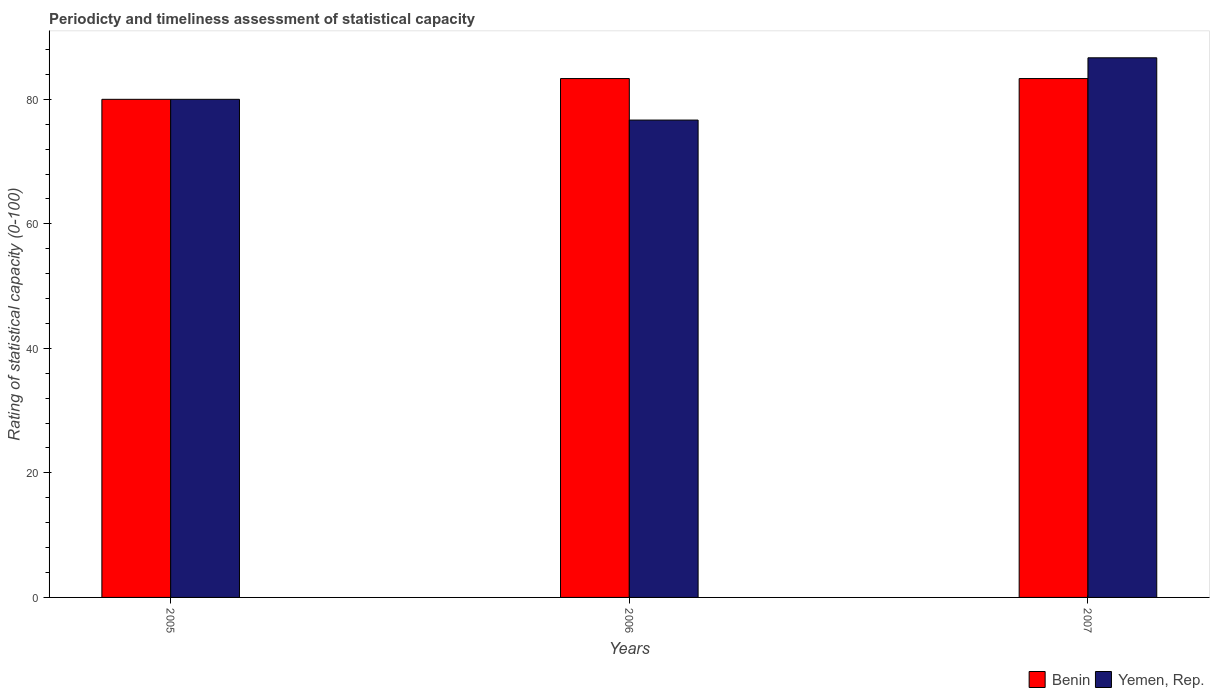How many different coloured bars are there?
Ensure brevity in your answer.  2. Are the number of bars per tick equal to the number of legend labels?
Your response must be concise. Yes. Are the number of bars on each tick of the X-axis equal?
Keep it short and to the point. Yes. How many bars are there on the 1st tick from the right?
Keep it short and to the point. 2. In how many cases, is the number of bars for a given year not equal to the number of legend labels?
Offer a terse response. 0. What is the rating of statistical capacity in Benin in 2007?
Make the answer very short. 83.33. Across all years, what is the maximum rating of statistical capacity in Yemen, Rep.?
Provide a short and direct response. 86.67. Across all years, what is the minimum rating of statistical capacity in Yemen, Rep.?
Make the answer very short. 76.67. In which year was the rating of statistical capacity in Benin maximum?
Keep it short and to the point. 2006. What is the total rating of statistical capacity in Benin in the graph?
Make the answer very short. 246.67. What is the difference between the rating of statistical capacity in Benin in 2006 and that in 2007?
Provide a succinct answer. 0. What is the difference between the rating of statistical capacity in Benin in 2007 and the rating of statistical capacity in Yemen, Rep. in 2005?
Your response must be concise. 3.33. What is the average rating of statistical capacity in Yemen, Rep. per year?
Offer a very short reply. 81.11. In the year 2005, what is the difference between the rating of statistical capacity in Yemen, Rep. and rating of statistical capacity in Benin?
Your answer should be compact. 0. What is the ratio of the rating of statistical capacity in Yemen, Rep. in 2005 to that in 2006?
Give a very brief answer. 1.04. Is the difference between the rating of statistical capacity in Yemen, Rep. in 2005 and 2007 greater than the difference between the rating of statistical capacity in Benin in 2005 and 2007?
Your answer should be very brief. No. In how many years, is the rating of statistical capacity in Benin greater than the average rating of statistical capacity in Benin taken over all years?
Your response must be concise. 2. What does the 1st bar from the left in 2005 represents?
Offer a terse response. Benin. What does the 1st bar from the right in 2005 represents?
Your answer should be very brief. Yemen, Rep. Are all the bars in the graph horizontal?
Keep it short and to the point. No. Does the graph contain grids?
Provide a short and direct response. No. Where does the legend appear in the graph?
Offer a very short reply. Bottom right. How are the legend labels stacked?
Your answer should be compact. Horizontal. What is the title of the graph?
Keep it short and to the point. Periodicty and timeliness assessment of statistical capacity. What is the label or title of the X-axis?
Provide a succinct answer. Years. What is the label or title of the Y-axis?
Make the answer very short. Rating of statistical capacity (0-100). What is the Rating of statistical capacity (0-100) in Benin in 2005?
Offer a terse response. 80. What is the Rating of statistical capacity (0-100) in Yemen, Rep. in 2005?
Provide a short and direct response. 80. What is the Rating of statistical capacity (0-100) in Benin in 2006?
Offer a terse response. 83.33. What is the Rating of statistical capacity (0-100) of Yemen, Rep. in 2006?
Provide a short and direct response. 76.67. What is the Rating of statistical capacity (0-100) of Benin in 2007?
Give a very brief answer. 83.33. What is the Rating of statistical capacity (0-100) of Yemen, Rep. in 2007?
Provide a short and direct response. 86.67. Across all years, what is the maximum Rating of statistical capacity (0-100) of Benin?
Your answer should be compact. 83.33. Across all years, what is the maximum Rating of statistical capacity (0-100) in Yemen, Rep.?
Offer a terse response. 86.67. Across all years, what is the minimum Rating of statistical capacity (0-100) in Yemen, Rep.?
Provide a short and direct response. 76.67. What is the total Rating of statistical capacity (0-100) in Benin in the graph?
Provide a succinct answer. 246.67. What is the total Rating of statistical capacity (0-100) of Yemen, Rep. in the graph?
Keep it short and to the point. 243.33. What is the difference between the Rating of statistical capacity (0-100) in Benin in 2005 and that in 2006?
Provide a succinct answer. -3.33. What is the difference between the Rating of statistical capacity (0-100) of Yemen, Rep. in 2005 and that in 2006?
Your answer should be very brief. 3.33. What is the difference between the Rating of statistical capacity (0-100) of Benin in 2005 and that in 2007?
Offer a terse response. -3.33. What is the difference between the Rating of statistical capacity (0-100) of Yemen, Rep. in 2005 and that in 2007?
Your answer should be compact. -6.67. What is the difference between the Rating of statistical capacity (0-100) of Yemen, Rep. in 2006 and that in 2007?
Offer a very short reply. -10. What is the difference between the Rating of statistical capacity (0-100) of Benin in 2005 and the Rating of statistical capacity (0-100) of Yemen, Rep. in 2006?
Ensure brevity in your answer.  3.33. What is the difference between the Rating of statistical capacity (0-100) of Benin in 2005 and the Rating of statistical capacity (0-100) of Yemen, Rep. in 2007?
Provide a succinct answer. -6.67. What is the difference between the Rating of statistical capacity (0-100) of Benin in 2006 and the Rating of statistical capacity (0-100) of Yemen, Rep. in 2007?
Provide a succinct answer. -3.33. What is the average Rating of statistical capacity (0-100) of Benin per year?
Provide a short and direct response. 82.22. What is the average Rating of statistical capacity (0-100) of Yemen, Rep. per year?
Provide a short and direct response. 81.11. In the year 2006, what is the difference between the Rating of statistical capacity (0-100) in Benin and Rating of statistical capacity (0-100) in Yemen, Rep.?
Provide a short and direct response. 6.67. In the year 2007, what is the difference between the Rating of statistical capacity (0-100) in Benin and Rating of statistical capacity (0-100) in Yemen, Rep.?
Your answer should be compact. -3.33. What is the ratio of the Rating of statistical capacity (0-100) in Yemen, Rep. in 2005 to that in 2006?
Ensure brevity in your answer.  1.04. What is the ratio of the Rating of statistical capacity (0-100) in Benin in 2006 to that in 2007?
Make the answer very short. 1. What is the ratio of the Rating of statistical capacity (0-100) in Yemen, Rep. in 2006 to that in 2007?
Make the answer very short. 0.88. What is the difference between the highest and the lowest Rating of statistical capacity (0-100) of Benin?
Your response must be concise. 3.33. What is the difference between the highest and the lowest Rating of statistical capacity (0-100) in Yemen, Rep.?
Offer a very short reply. 10. 